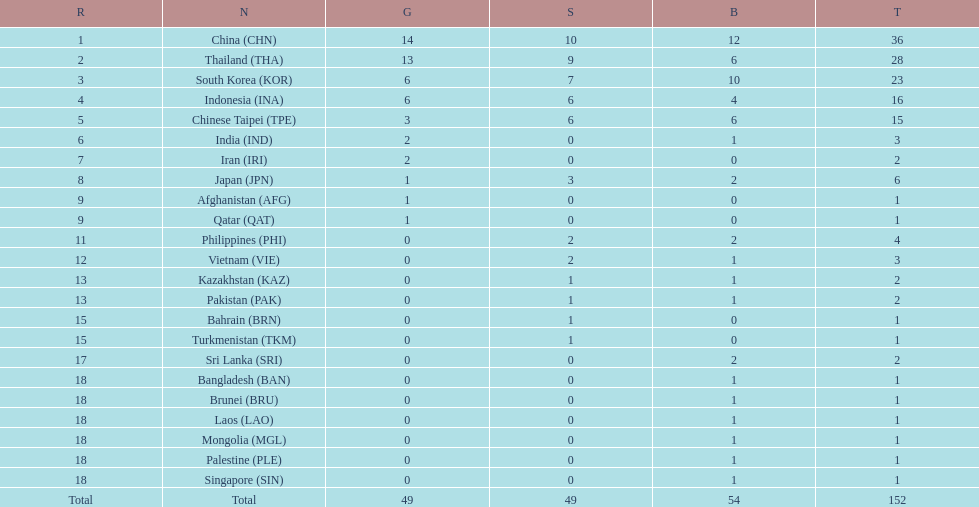How many more medals did india earn compared to pakistan? 1. 